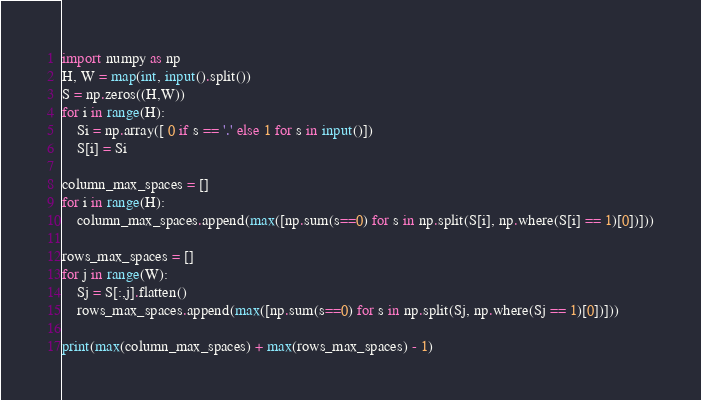Convert code to text. <code><loc_0><loc_0><loc_500><loc_500><_Python_>import numpy as np
H, W = map(int, input().split())
S = np.zeros((H,W))
for i in range(H):
    Si = np.array([ 0 if s == '.' else 1 for s in input()])
    S[i] = Si

column_max_spaces = []
for i in range(H):
    column_max_spaces.append(max([np.sum(s==0) for s in np.split(S[i], np.where(S[i] == 1)[0])]))
    
rows_max_spaces = []
for j in range(W):
    Sj = S[:,j].flatten()
    rows_max_spaces.append(max([np.sum(s==0) for s in np.split(Sj, np.where(Sj == 1)[0])]))

print(max(column_max_spaces) + max(rows_max_spaces) - 1)</code> 